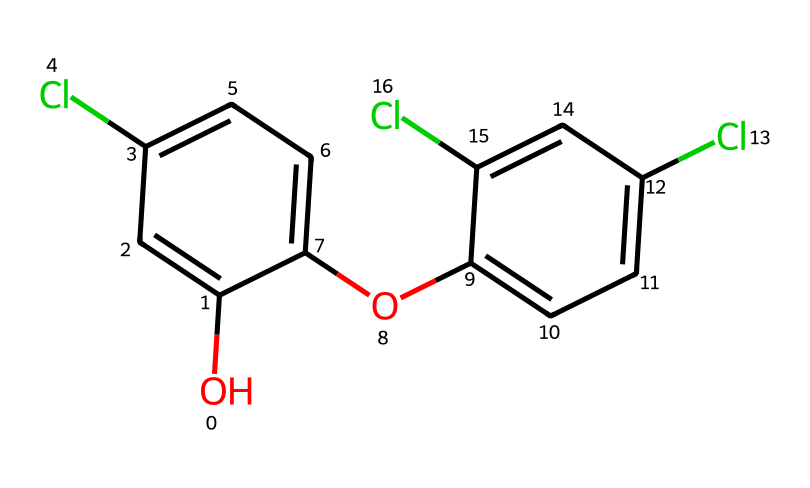What is the total number of chlorine atoms in this structure? The SMILES representation shows three "Cl" atoms, which are present at different positions in the structure. By counting each "Cl" in the SMILES string, it is evident there are three chlorine atoms.
Answer: three How many benzene rings are in this chemical structure? The structure contains two distinct aromatic rings, each represented by a series of connected carbon atoms and associated double bonds. Counting the two sets confirms the presence of two benzene rings.
Answer: two What is the molecular type of triclosan? Triclosan is classified as a chlorinated phenolic compound due to the presence of phenol (the hydroxyl group) and multiple chlorine substituents on the aromatic rings.
Answer: chlorinated phenolic Which functional group is present in this chemical? The hydroxyl group ("-OH") is clearly indicated in the SMILES as "O" connected to a carbon atom, which is characteristic of alcohols and phenols.
Answer: hydroxyl What is the common use of triclosan? Triclosan is commonly used as an antibacterial agent in various personal care products and cleaning agents. Its application highlights its effectiveness against microorganisms, which aligns with its structure and functionality.
Answer: antibacterial agent Is this chemical considered safe for use? Due to concerns regarding its safety and potential environmental impact, triclosan has faced scrutiny and regulatory action, leading to its classification as toxic in certain contexts.
Answer: no 